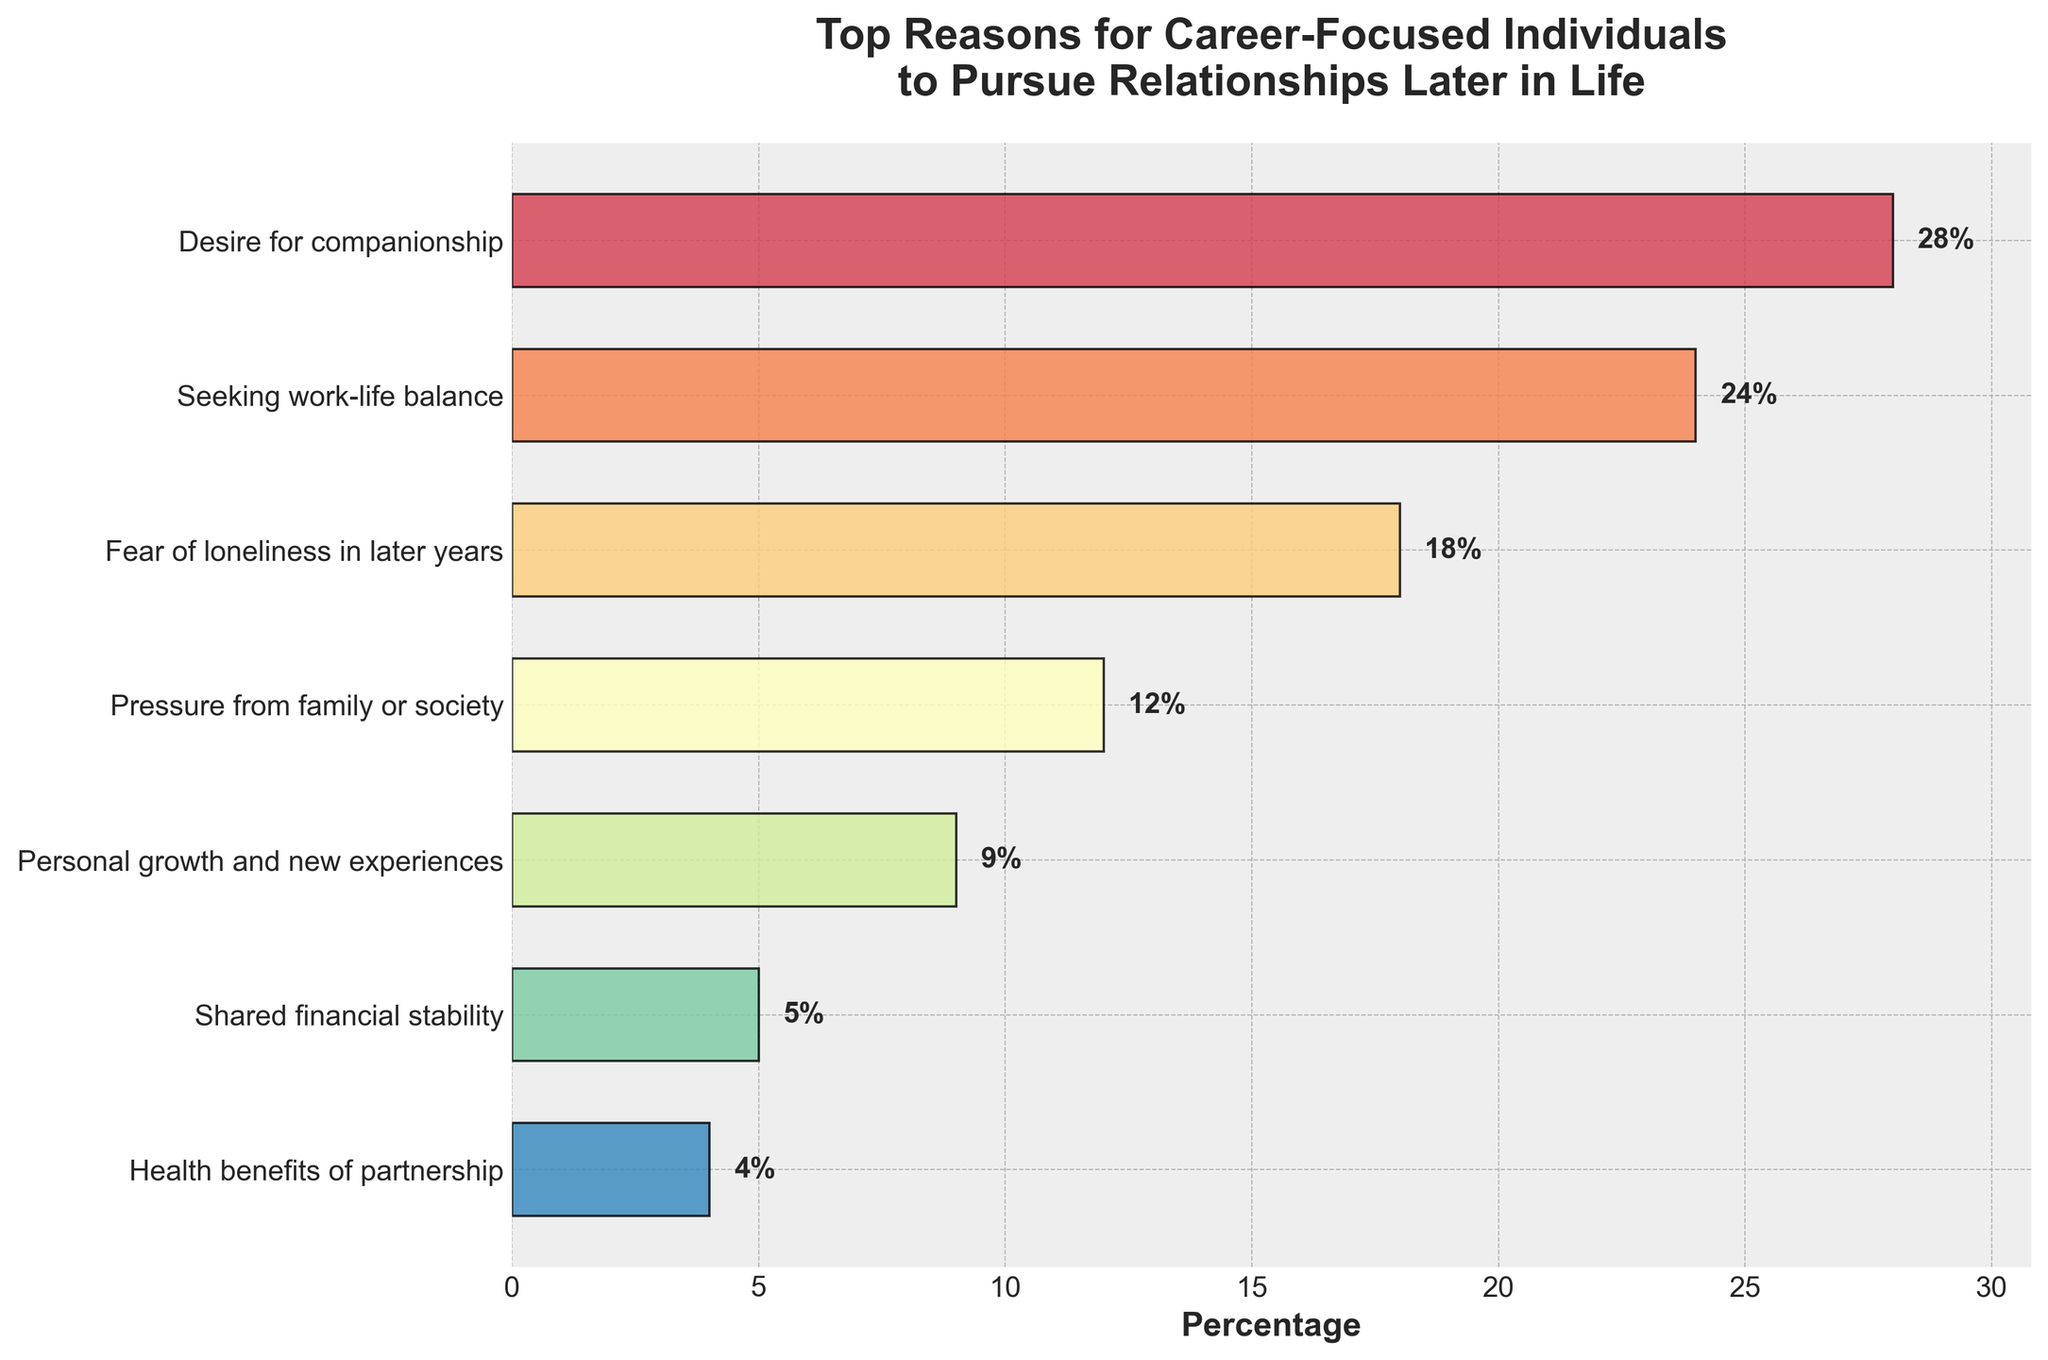What is the most cited reason for career-focused individuals to pursue relationships later in life? The length of the bars visually represents the percentage. The longest bar corresponds to "Desire for companionship" at 28%.
Answer: Desire for companionship Which reason has a higher percentage, "Fear of loneliness in later years" or "Shared financial stability"? By comparing the lengths of the bars, "Fear of loneliness in later years" is higher at 18% compared to "Shared financial stability" which is at 5%.
Answer: Fear of loneliness in later years What is the combined percentage of the top two reasons cited for pursuing relationships later in life? The top two reasons are "Desire for companionship" (28%) and "Seeking work-life balance" (24%). Their combined percentage is 28% + 24%.
Answer: 52% How much more popular is "Pressure from family or society" than "Health benefits of partnership"? "Pressure from family or society" is 12% and "Health benefits of partnership" is 4%. The difference is 12% - 4%.
Answer: 8% What are the bottom three reasons cited for pursuing relationships later in life in terms of percentages? By examining the figure, the bottom three reasons are "Shared financial stability" at 5%, "Health benefits of partnership" at 4%, and "Personal growth and new experiences" at 9%.
Answer: Personal growth and new experiences, Shared financial stability, Health benefits of partnership How does the percentage of "Seeking work-life balance" compare to the average of all the reasons? First, sum all percentages (28% + 24% + 18% + 12% + 9% + 5% + 4%) = 100%. There are 7 reasons, so the average is 100% / 7 ≈ 14.29%. "Seeking work-life balance" at 24% is greater than the average.
Answer: Greater than average What percentage of respondents cited "Desire for companionship" and "Health benefits of partnership" combined? "Desire for companionship" is 28% and "Health benefits of partnership" is 4%. Their combined percentage is 28% + 4%.
Answer: 32% How does the percentage of "Shared financial stability" compare to "Personal growth and new experiences"? "Shared financial stability" is 5% while "Personal growth and new experiences" is 9%. "Shared financial stability" is less than "Personal growth and new experiences".
Answer: Less Which reason is cited less frequently than 10% but more than 4%? The reason falling in this range is "Personal growth and new experiences" at 9%.
Answer: Personal growth and new experiences If the top three reasons were combined into a single category, what percentage would they represent? The top three reasons are "Desire for companionship" at 28%, "Seeking work-life balance" at 24%, and "Fear of loneliness in later years" at 18%. Their combined percentage is 28% + 24% + 18%.
Answer: 70% 